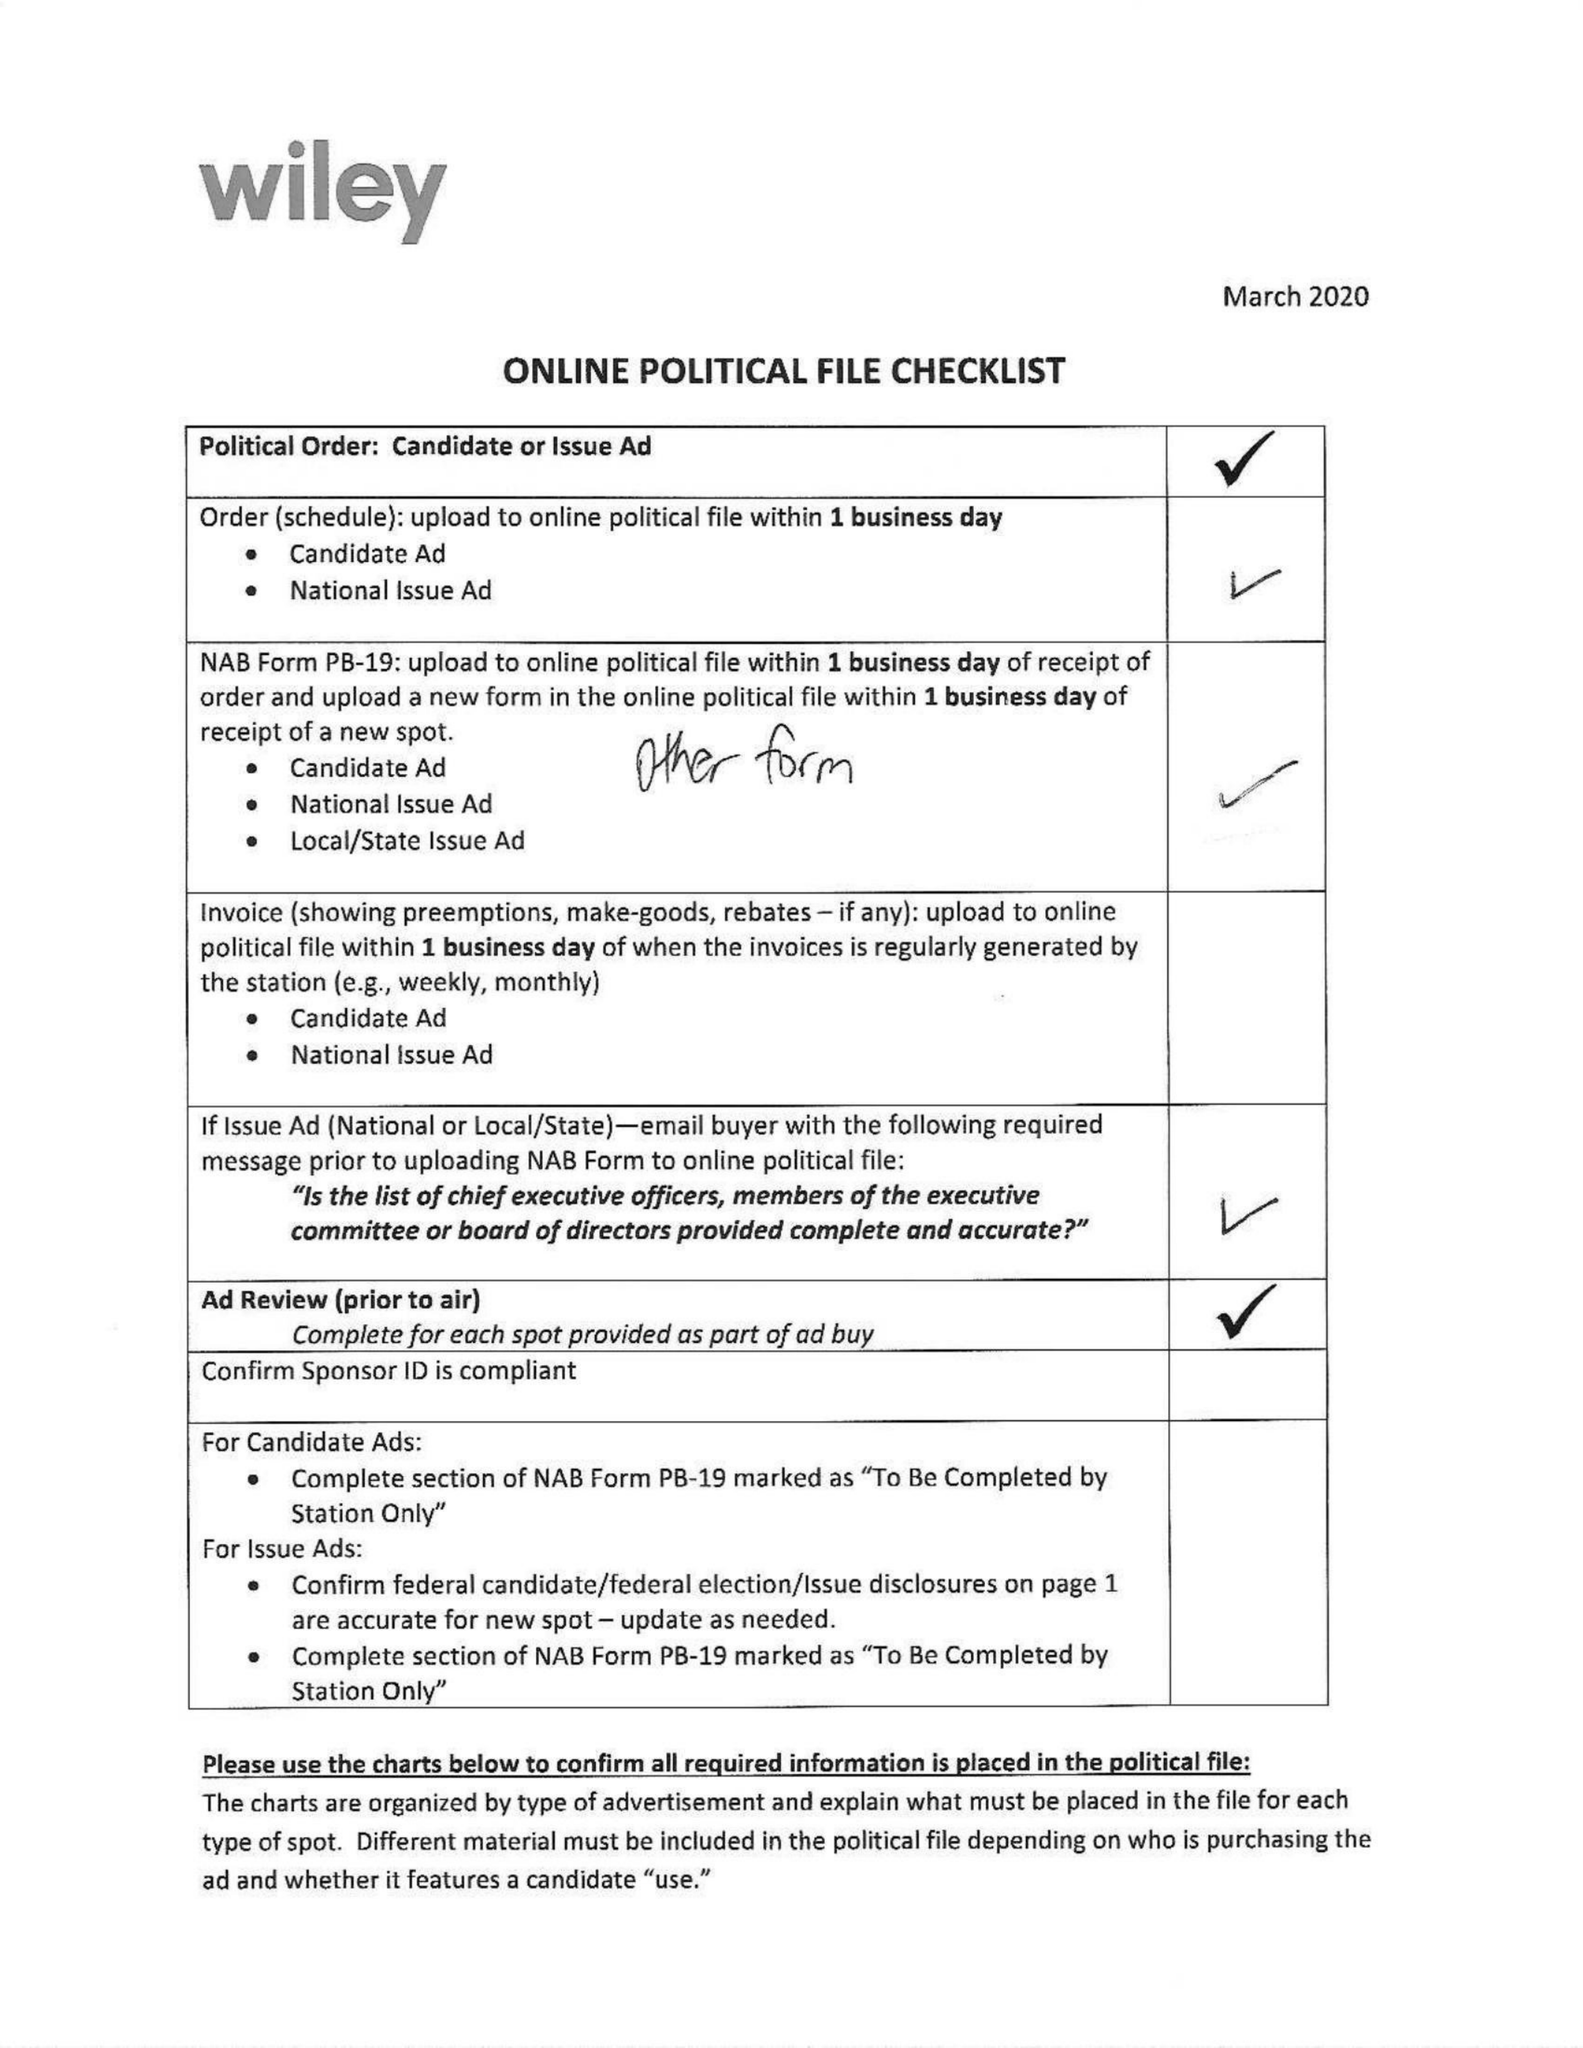What is the value for the flight_to?
Answer the question using a single word or phrase. 08/16/20 